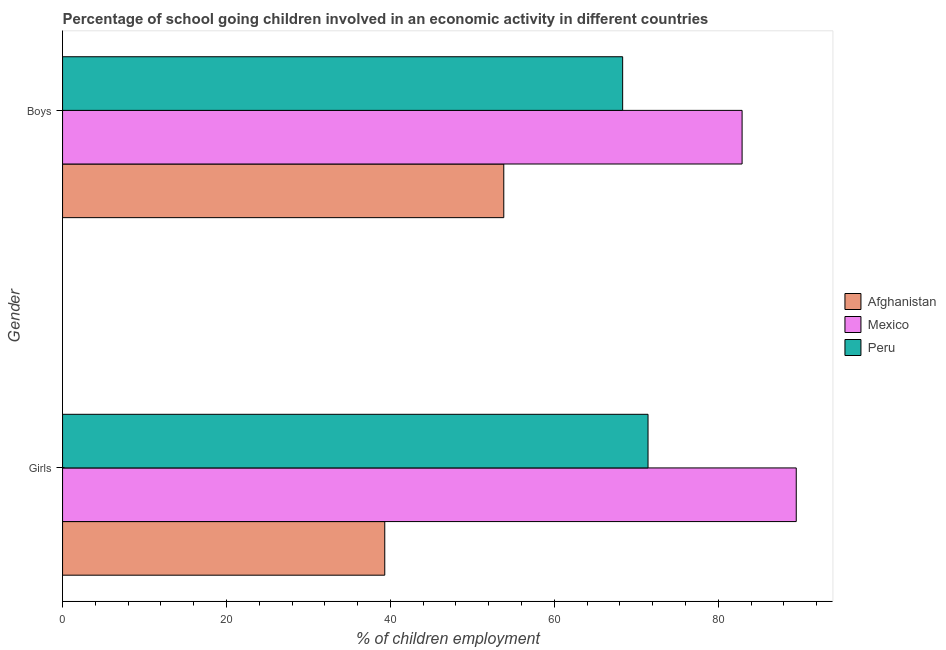How many groups of bars are there?
Provide a succinct answer. 2. How many bars are there on the 2nd tick from the top?
Give a very brief answer. 3. What is the label of the 2nd group of bars from the top?
Give a very brief answer. Girls. What is the percentage of school going boys in Afghanistan?
Keep it short and to the point. 53.83. Across all countries, what is the maximum percentage of school going girls?
Offer a terse response. 89.51. Across all countries, what is the minimum percentage of school going girls?
Give a very brief answer. 39.31. In which country was the percentage of school going girls minimum?
Provide a short and direct response. Afghanistan. What is the total percentage of school going girls in the graph?
Your answer should be very brief. 200.25. What is the difference between the percentage of school going boys in Mexico and that in Peru?
Make the answer very short. 14.57. What is the difference between the percentage of school going girls in Afghanistan and the percentage of school going boys in Mexico?
Offer a terse response. -43.6. What is the average percentage of school going boys per country?
Ensure brevity in your answer.  68.36. What is the difference between the percentage of school going boys and percentage of school going girls in Afghanistan?
Provide a succinct answer. 14.52. What is the ratio of the percentage of school going boys in Afghanistan to that in Mexico?
Offer a very short reply. 0.65. How many bars are there?
Your response must be concise. 6. Are all the bars in the graph horizontal?
Provide a short and direct response. Yes. Are the values on the major ticks of X-axis written in scientific E-notation?
Your answer should be compact. No. Does the graph contain any zero values?
Offer a very short reply. No. What is the title of the graph?
Make the answer very short. Percentage of school going children involved in an economic activity in different countries. Does "Malawi" appear as one of the legend labels in the graph?
Your response must be concise. No. What is the label or title of the X-axis?
Offer a terse response. % of children employment. What is the % of children employment in Afghanistan in Girls?
Your answer should be compact. 39.31. What is the % of children employment in Mexico in Girls?
Offer a very short reply. 89.51. What is the % of children employment of Peru in Girls?
Provide a succinct answer. 71.43. What is the % of children employment in Afghanistan in Boys?
Give a very brief answer. 53.83. What is the % of children employment in Mexico in Boys?
Provide a succinct answer. 82.91. What is the % of children employment in Peru in Boys?
Your response must be concise. 68.33. Across all Gender, what is the maximum % of children employment in Afghanistan?
Your answer should be very brief. 53.83. Across all Gender, what is the maximum % of children employment in Mexico?
Your answer should be compact. 89.51. Across all Gender, what is the maximum % of children employment in Peru?
Provide a succinct answer. 71.43. Across all Gender, what is the minimum % of children employment of Afghanistan?
Offer a terse response. 39.31. Across all Gender, what is the minimum % of children employment in Mexico?
Your answer should be very brief. 82.91. Across all Gender, what is the minimum % of children employment of Peru?
Your answer should be very brief. 68.33. What is the total % of children employment of Afghanistan in the graph?
Your response must be concise. 93.14. What is the total % of children employment in Mexico in the graph?
Your answer should be very brief. 172.42. What is the total % of children employment in Peru in the graph?
Your response must be concise. 139.76. What is the difference between the % of children employment in Afghanistan in Girls and that in Boys?
Ensure brevity in your answer.  -14.52. What is the difference between the % of children employment in Mexico in Girls and that in Boys?
Provide a succinct answer. 6.61. What is the difference between the % of children employment in Peru in Girls and that in Boys?
Keep it short and to the point. 3.1. What is the difference between the % of children employment in Afghanistan in Girls and the % of children employment in Mexico in Boys?
Your answer should be very brief. -43.6. What is the difference between the % of children employment in Afghanistan in Girls and the % of children employment in Peru in Boys?
Provide a short and direct response. -29.02. What is the difference between the % of children employment in Mexico in Girls and the % of children employment in Peru in Boys?
Give a very brief answer. 21.18. What is the average % of children employment of Afghanistan per Gender?
Make the answer very short. 46.57. What is the average % of children employment in Mexico per Gender?
Provide a short and direct response. 86.21. What is the average % of children employment in Peru per Gender?
Keep it short and to the point. 69.88. What is the difference between the % of children employment in Afghanistan and % of children employment in Mexico in Girls?
Your answer should be very brief. -50.2. What is the difference between the % of children employment of Afghanistan and % of children employment of Peru in Girls?
Offer a terse response. -32.12. What is the difference between the % of children employment in Mexico and % of children employment in Peru in Girls?
Ensure brevity in your answer.  18.08. What is the difference between the % of children employment in Afghanistan and % of children employment in Mexico in Boys?
Ensure brevity in your answer.  -29.08. What is the difference between the % of children employment of Afghanistan and % of children employment of Peru in Boys?
Make the answer very short. -14.5. What is the difference between the % of children employment in Mexico and % of children employment in Peru in Boys?
Keep it short and to the point. 14.57. What is the ratio of the % of children employment of Afghanistan in Girls to that in Boys?
Ensure brevity in your answer.  0.73. What is the ratio of the % of children employment of Mexico in Girls to that in Boys?
Your response must be concise. 1.08. What is the ratio of the % of children employment of Peru in Girls to that in Boys?
Give a very brief answer. 1.05. What is the difference between the highest and the second highest % of children employment of Afghanistan?
Offer a terse response. 14.52. What is the difference between the highest and the second highest % of children employment of Mexico?
Offer a very short reply. 6.61. What is the difference between the highest and the second highest % of children employment of Peru?
Offer a very short reply. 3.1. What is the difference between the highest and the lowest % of children employment in Afghanistan?
Give a very brief answer. 14.52. What is the difference between the highest and the lowest % of children employment in Mexico?
Give a very brief answer. 6.61. What is the difference between the highest and the lowest % of children employment in Peru?
Offer a terse response. 3.1. 